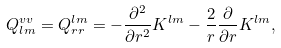Convert formula to latex. <formula><loc_0><loc_0><loc_500><loc_500>Q ^ { v v } _ { l m } = Q ^ { l m } _ { r r } = - \frac { \partial ^ { 2 } } { \partial r ^ { 2 } } K ^ { l m } - \frac { 2 } { r } \frac { \partial } { \partial r } K ^ { l m } ,</formula> 